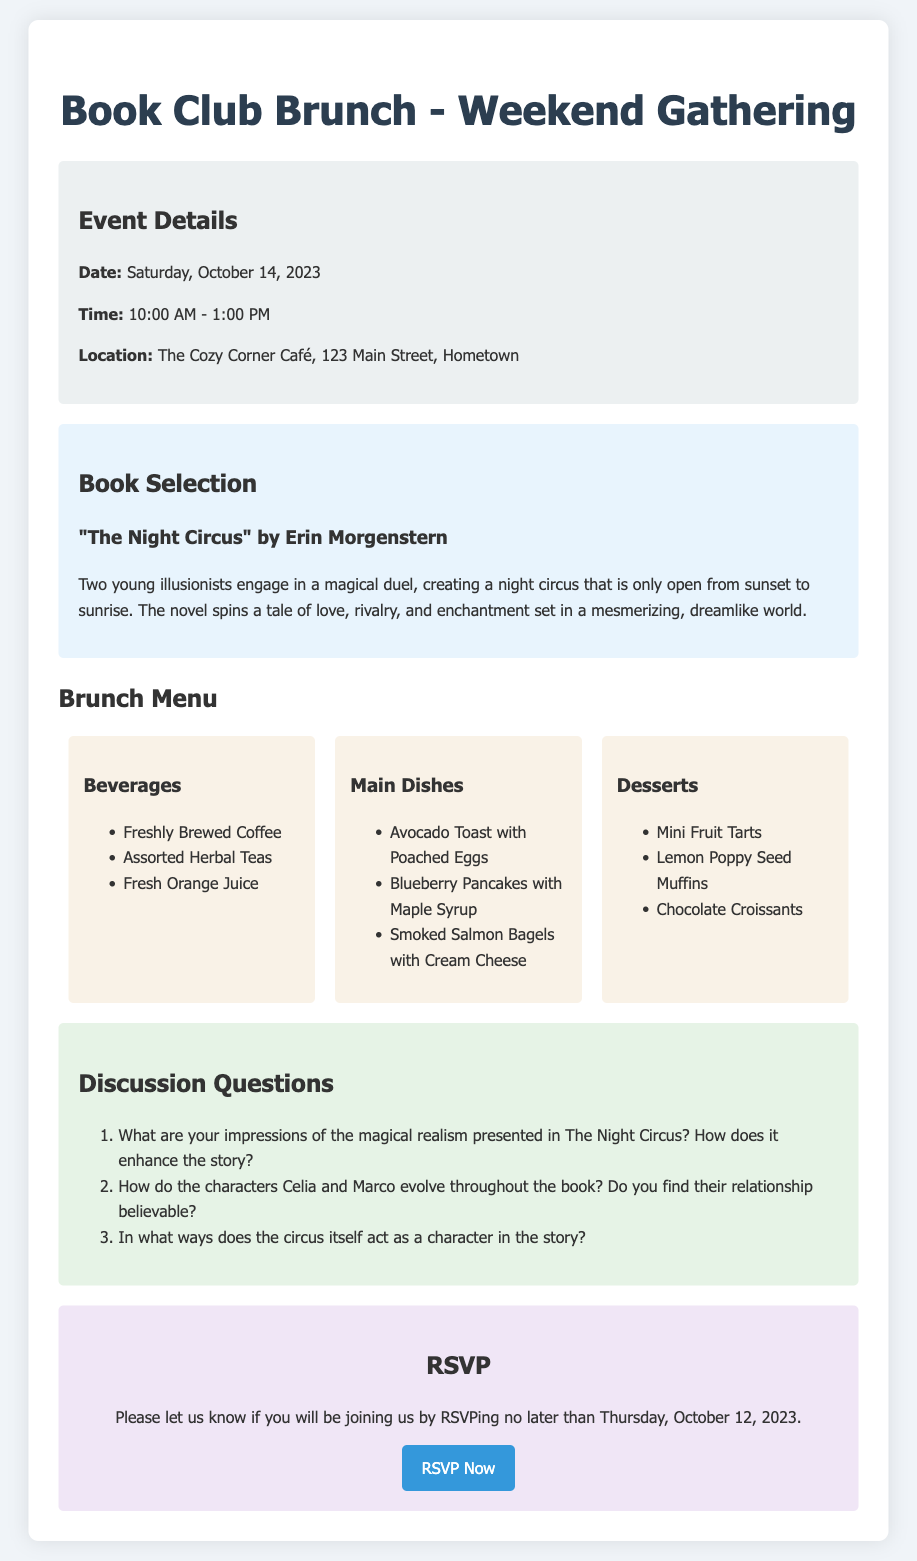What is the date of the Book Club Brunch? The date is mentioned in the event details section of the document.
Answer: Saturday, October 14, 2023 What is the time of the event? The time is specified in the event details section of the document.
Answer: 10:00 AM - 1:00 PM Where is the location of the brunch? The location is provided in the event details section of the document.
Answer: The Cozy Corner Café, 123 Main Street, Hometown What book is selected for the discussion? The book selection is listed in the corresponding section of the document.
Answer: "The Night Circus" by Erin Morgenstern How many main dishes are listed in the brunch menu? The total number of main dishes can be counted from the menu section.
Answer: 3 What is one of the discussion questions about the characters? The discussion questions include inquiries about the characters, specifically in relation to their evolution.
Answer: How do the characters Celia and Marco evolve throughout the book? Do you find their relationship believable? What is the RSVP deadline? The deadline for RSVPing is stated in the RSVP section of the document.
Answer: Thursday, October 12, 2023 What type of beverage is offered at the brunch? The menu section lists the beverages available at the brunch.
Answer: Freshly Brewed Coffee What should you do to RSVP? The action required to RSVP is mentioned in the RSVP section of the document.
Answer: Email bookclub@cozycornercafe.com 